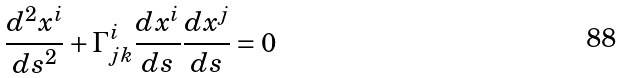Convert formula to latex. <formula><loc_0><loc_0><loc_500><loc_500>\frac { d ^ { 2 } x ^ { i } } { d s ^ { 2 } } + \Gamma ^ { i } _ { j k } \frac { d x ^ { i } } { d s } \frac { d x ^ { j } } { d s } = 0 \, \</formula> 